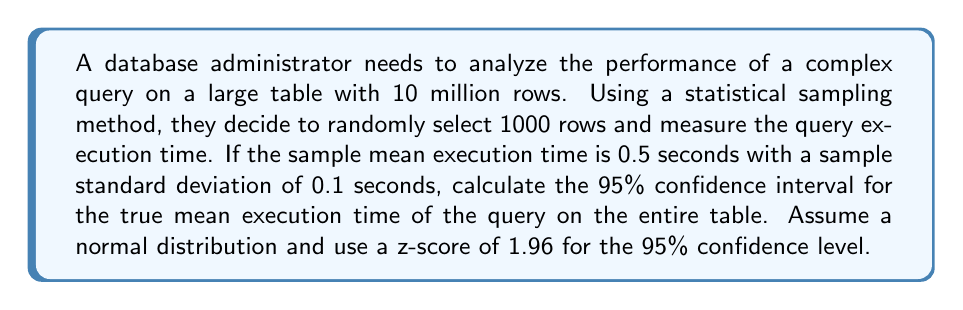Help me with this question. To calculate the confidence interval, we'll follow these steps:

1. Identify the given information:
   - Sample size (n) = 1000
   - Sample mean ($\bar{x}$) = 0.5 seconds
   - Sample standard deviation (s) = 0.1 seconds
   - Confidence level = 95% (z-score = 1.96)

2. Calculate the standard error (SE) of the mean:
   $$ SE = \frac{s}{\sqrt{n}} = \frac{0.1}{\sqrt{1000}} = \frac{0.1}{31.6228} \approx 0.003162 $$

3. Calculate the margin of error (ME):
   $$ ME = z \times SE = 1.96 \times 0.003162 \approx 0.006198 $$

4. Determine the confidence interval:
   - Lower bound: $\bar{x} - ME = 0.5 - 0.006198 \approx 0.493802$
   - Upper bound: $\bar{x} + ME = 0.5 + 0.006198 \approx 0.506198$

5. Express the confidence interval:
   $$ (0.493802, 0.506198) $$

Therefore, we can be 95% confident that the true mean execution time for the query on the entire table falls between 0.493802 and 0.506198 seconds.
Answer: (0.493802, 0.506198) seconds 